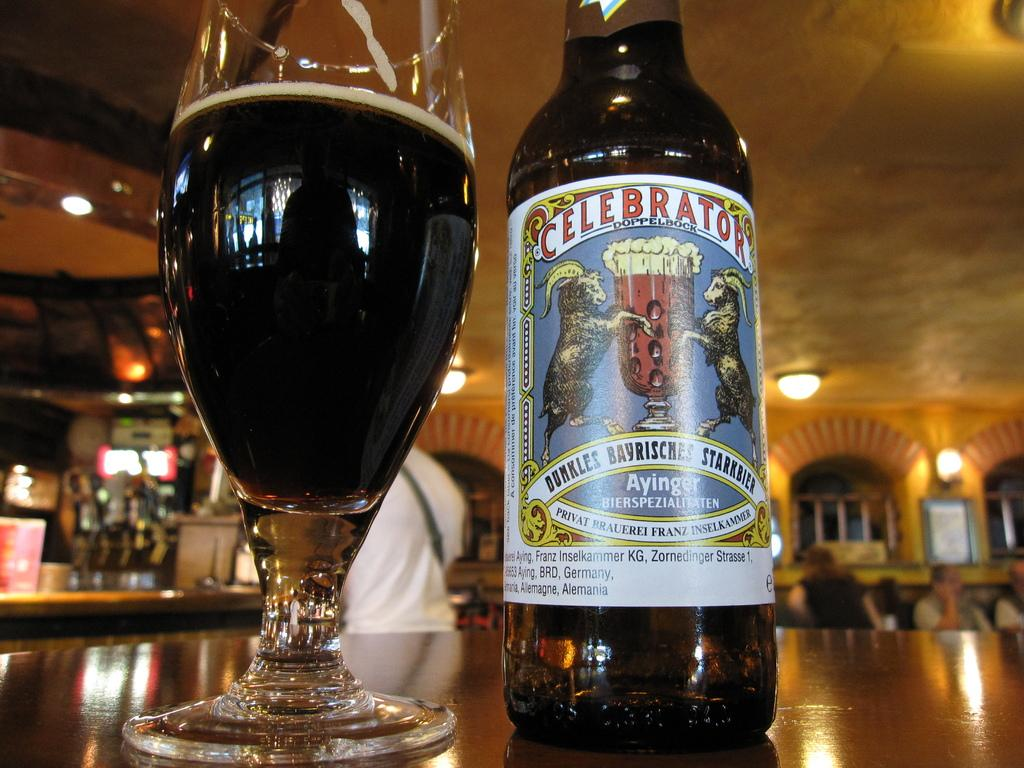<image>
Give a short and clear explanation of the subsequent image. a glass of dark beer next to its bottle called celebrator 